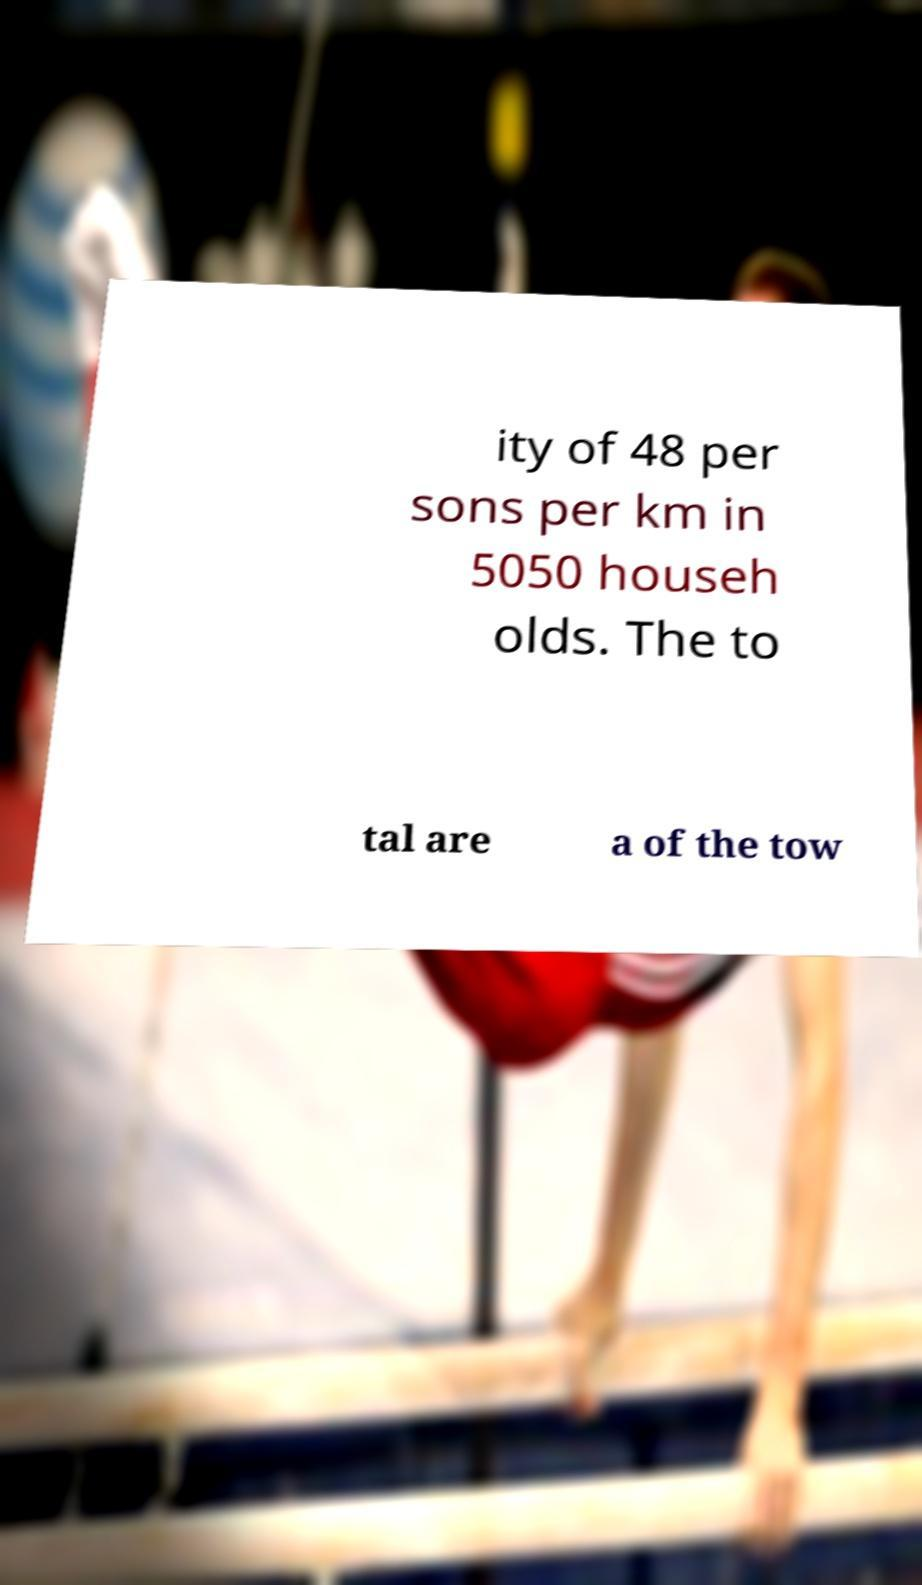Can you read and provide the text displayed in the image?This photo seems to have some interesting text. Can you extract and type it out for me? ity of 48 per sons per km in 5050 househ olds. The to tal are a of the tow 